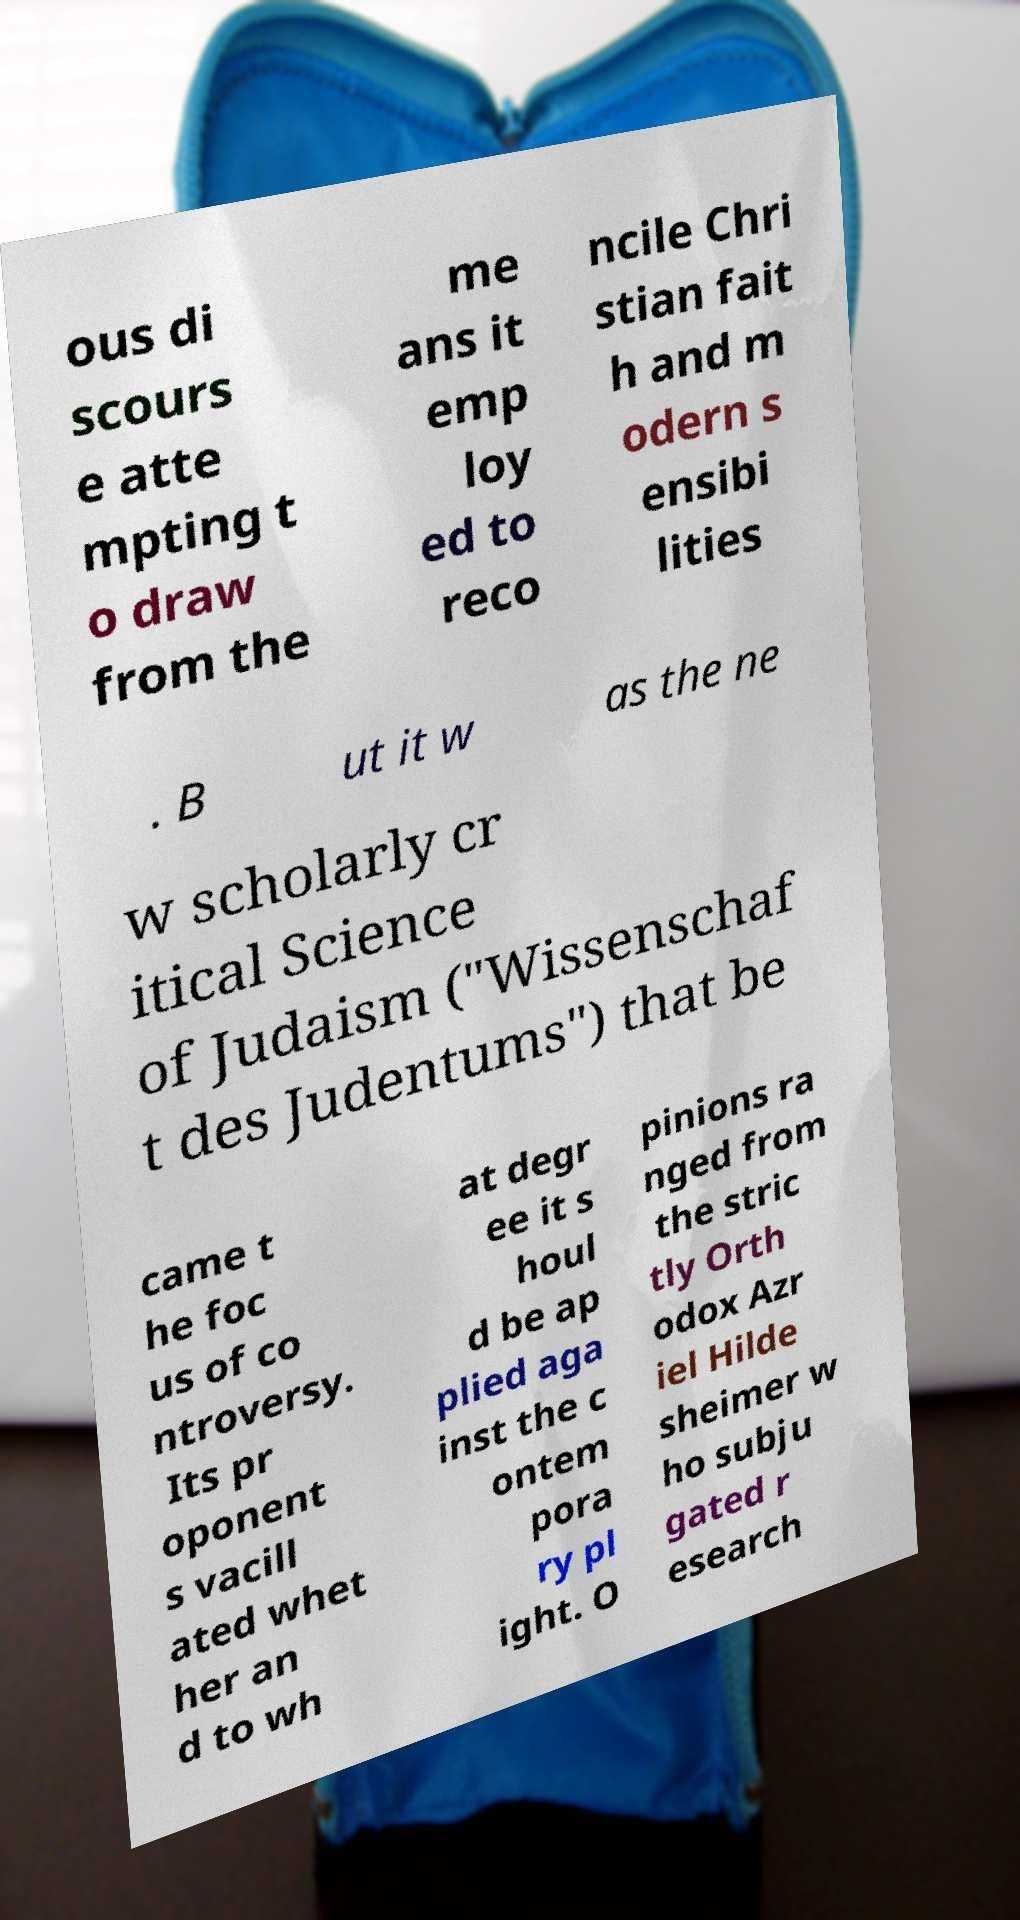Can you accurately transcribe the text from the provided image for me? ous di scours e atte mpting t o draw from the me ans it emp loy ed to reco ncile Chri stian fait h and m odern s ensibi lities . B ut it w as the ne w scholarly cr itical Science of Judaism ("Wissenschaf t des Judentums") that be came t he foc us of co ntroversy. Its pr oponent s vacill ated whet her an d to wh at degr ee it s houl d be ap plied aga inst the c ontem pora ry pl ight. O pinions ra nged from the stric tly Orth odox Azr iel Hilde sheimer w ho subju gated r esearch 